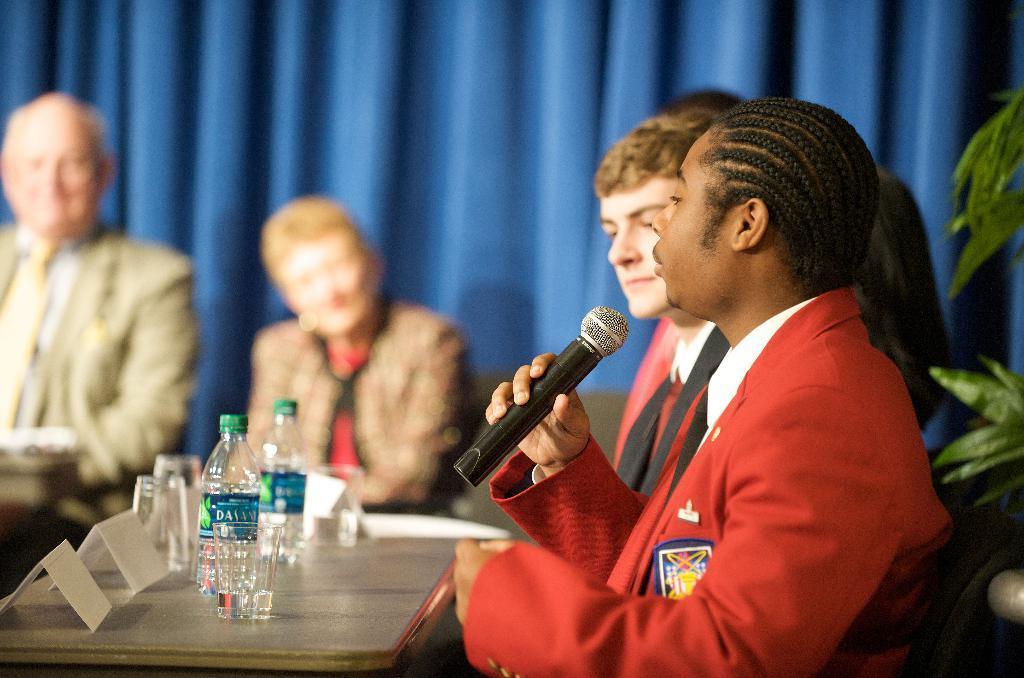In one or two sentences, can you explain what this image depicts? In this image I can see group of people sitting in front of the table and one person is holding the mic. On the table there are bottles,glasses and the boards. There is a plant and the curtain. 